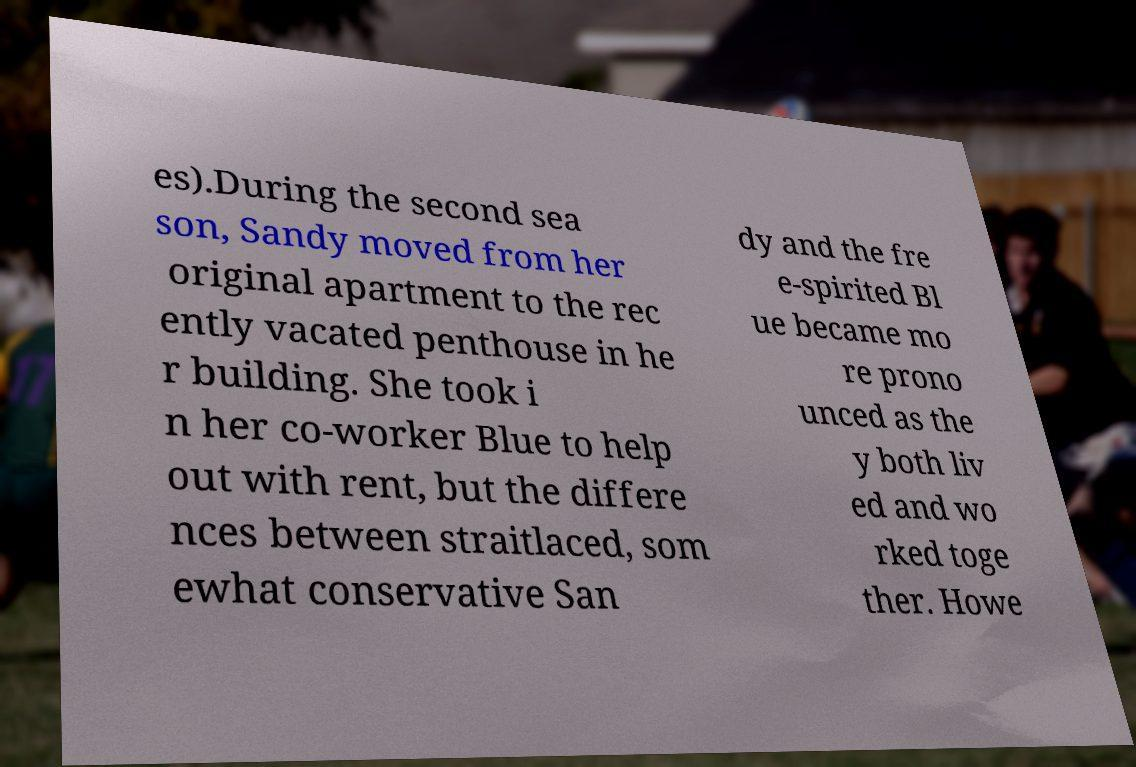Could you assist in decoding the text presented in this image and type it out clearly? es).During the second sea son, Sandy moved from her original apartment to the rec ently vacated penthouse in he r building. She took i n her co-worker Blue to help out with rent, but the differe nces between straitlaced, som ewhat conservative San dy and the fre e-spirited Bl ue became mo re prono unced as the y both liv ed and wo rked toge ther. Howe 